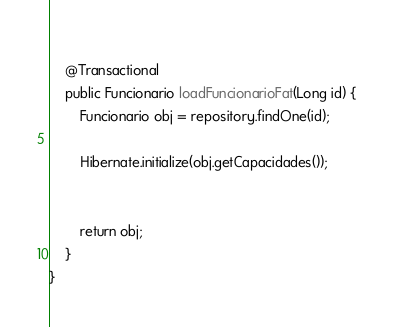Convert code to text. <code><loc_0><loc_0><loc_500><loc_500><_Java_>	
	@Transactional
	public Funcionario loadFuncionarioFat(Long id) {
		Funcionario obj = repository.findOne(id);	
		
		Hibernate.initialize(obj.getCapacidades());
		
		
		return obj;
	}
}
</code> 